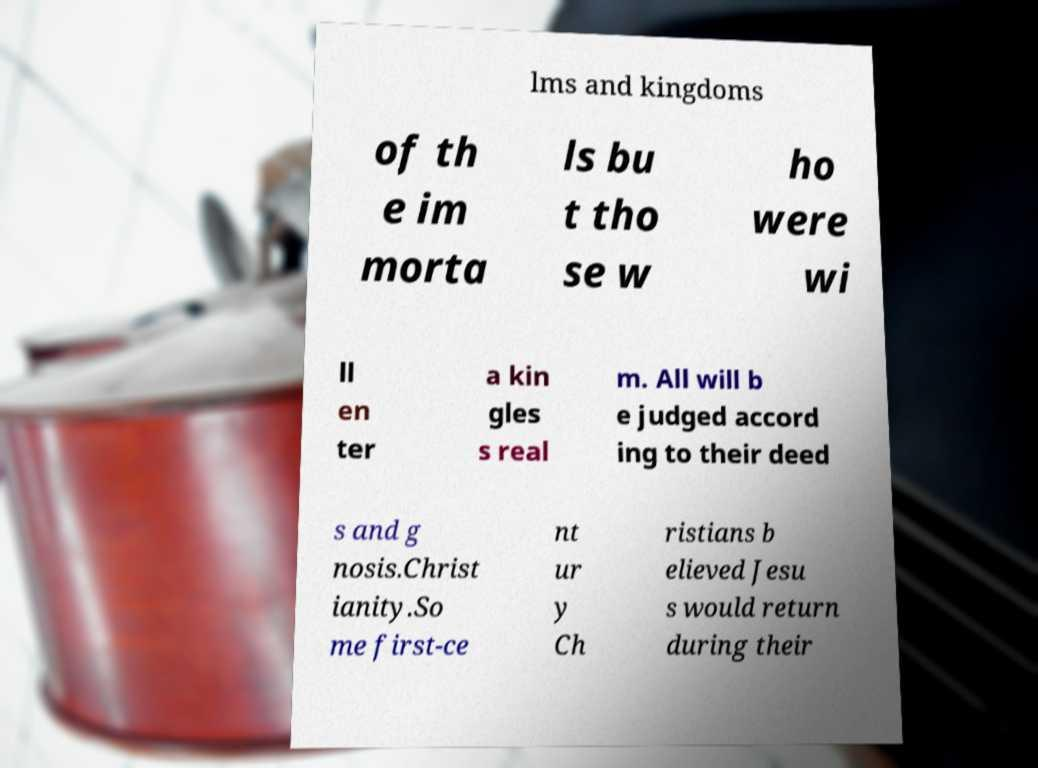Could you assist in decoding the text presented in this image and type it out clearly? lms and kingdoms of th e im morta ls bu t tho se w ho were wi ll en ter a kin gles s real m. All will b e judged accord ing to their deed s and g nosis.Christ ianity.So me first-ce nt ur y Ch ristians b elieved Jesu s would return during their 